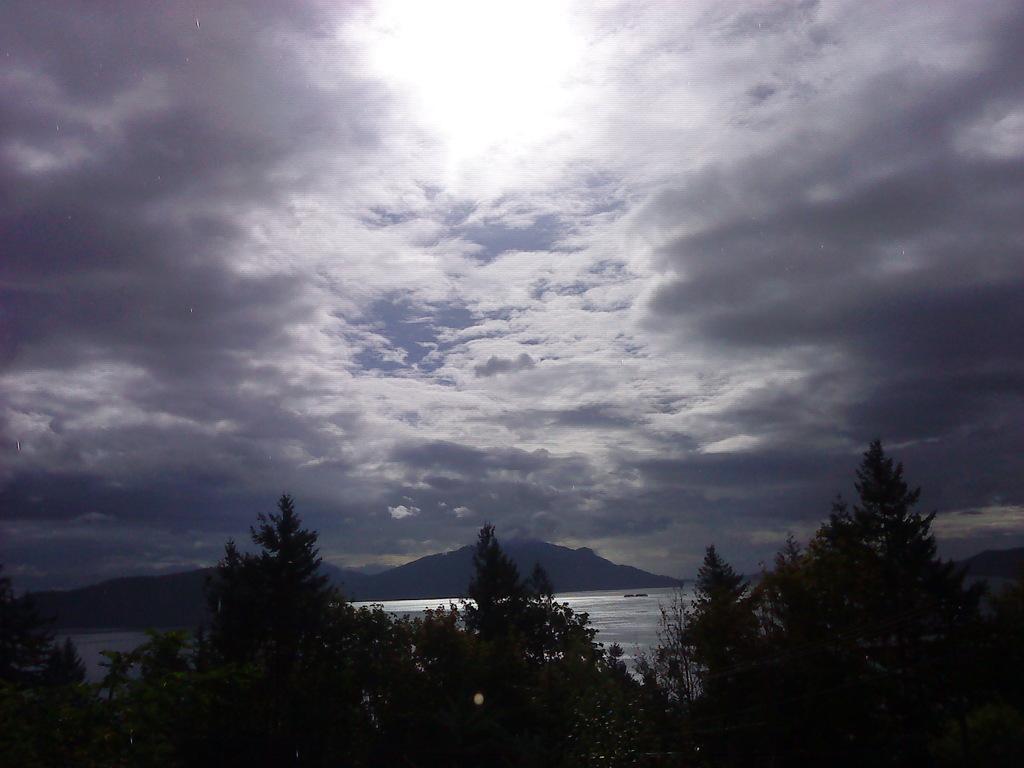Describe this image in one or two sentences. In the given image i can see a mountains,trees,water and sky. 